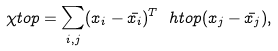<formula> <loc_0><loc_0><loc_500><loc_500>\chi t o p = { \sum _ { i , j } } ( x _ { i } - \bar { x _ { i } } ) ^ { T } \ h t o p ( x _ { j } - \bar { x _ { j } } ) ,</formula> 